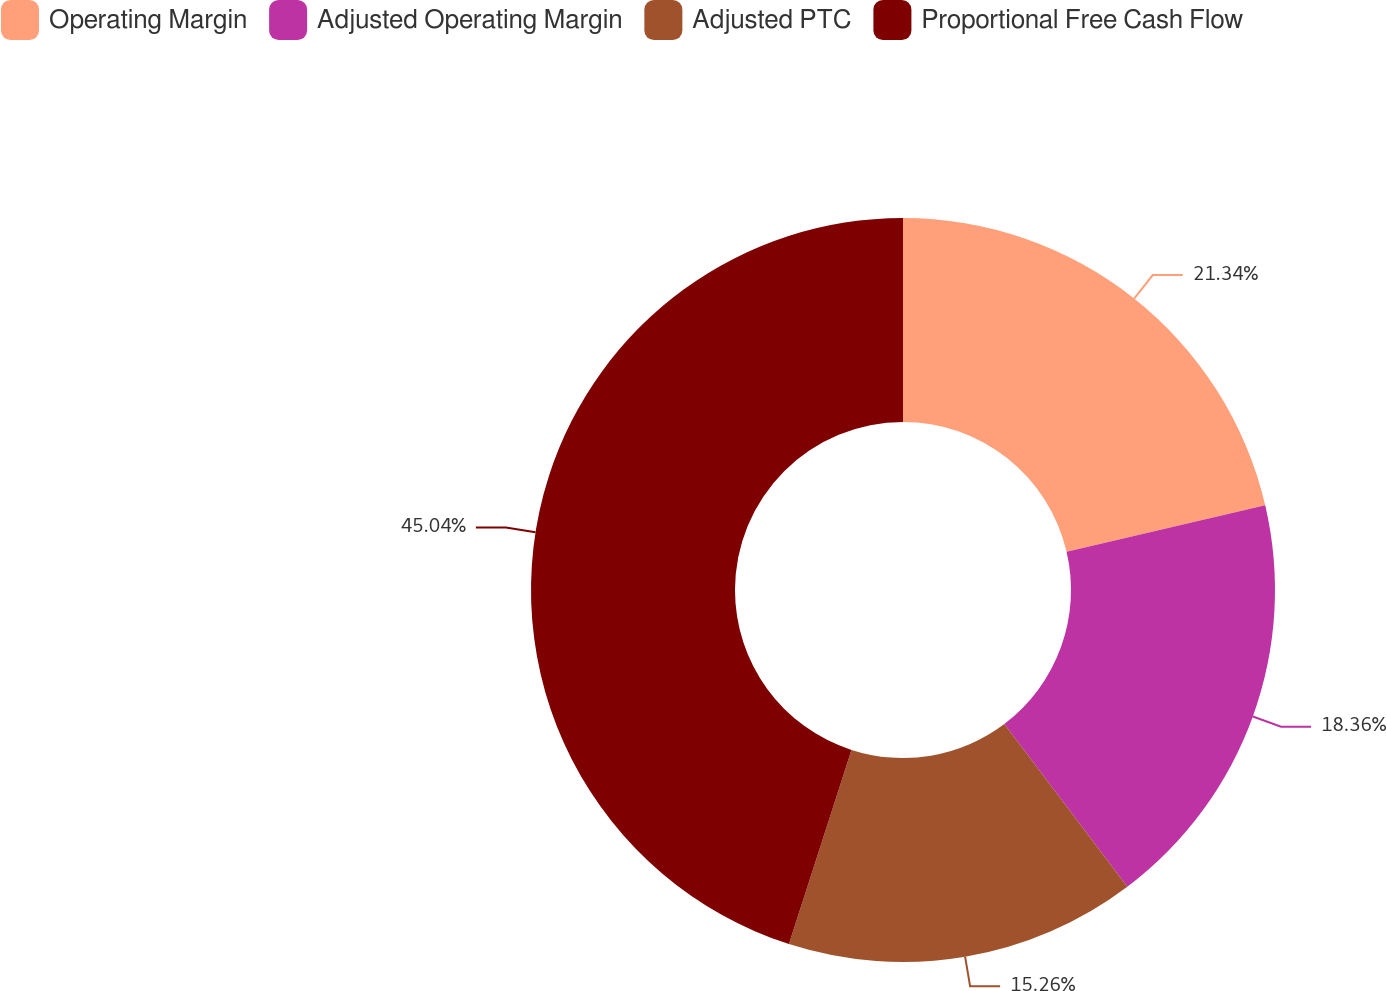Convert chart to OTSL. <chart><loc_0><loc_0><loc_500><loc_500><pie_chart><fcel>Operating Margin<fcel>Adjusted Operating Margin<fcel>Adjusted PTC<fcel>Proportional Free Cash Flow<nl><fcel>21.34%<fcel>18.36%<fcel>15.26%<fcel>45.04%<nl></chart> 